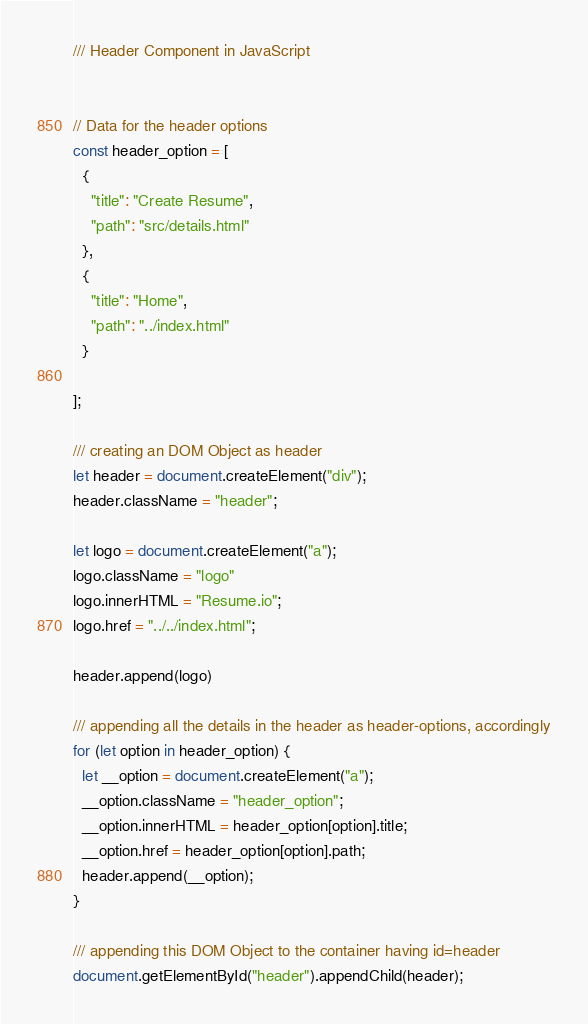Convert code to text. <code><loc_0><loc_0><loc_500><loc_500><_JavaScript_>/// Header Component in JavaScript


// Data for the header options
const header_option = [
  {
    "title": "Create Resume",
    "path": "src/details.html"
  },
  {
    "title": "Home",
    "path": "../index.html"
  }
  
];

/// creating an DOM Object as header
let header = document.createElement("div");
header.className = "header";

let logo = document.createElement("a");
logo.className = "logo"
logo.innerHTML = "Resume.io";
logo.href = "../../index.html";

header.append(logo)

/// appending all the details in the header as header-options, accordingly
for (let option in header_option) {
  let __option = document.createElement("a");
  __option.className = "header_option";
  __option.innerHTML = header_option[option].title;
  __option.href = header_option[option].path;
  header.append(__option);
}

/// appending this DOM Object to the container having id=header
document.getElementById("header").appendChild(header);

</code> 